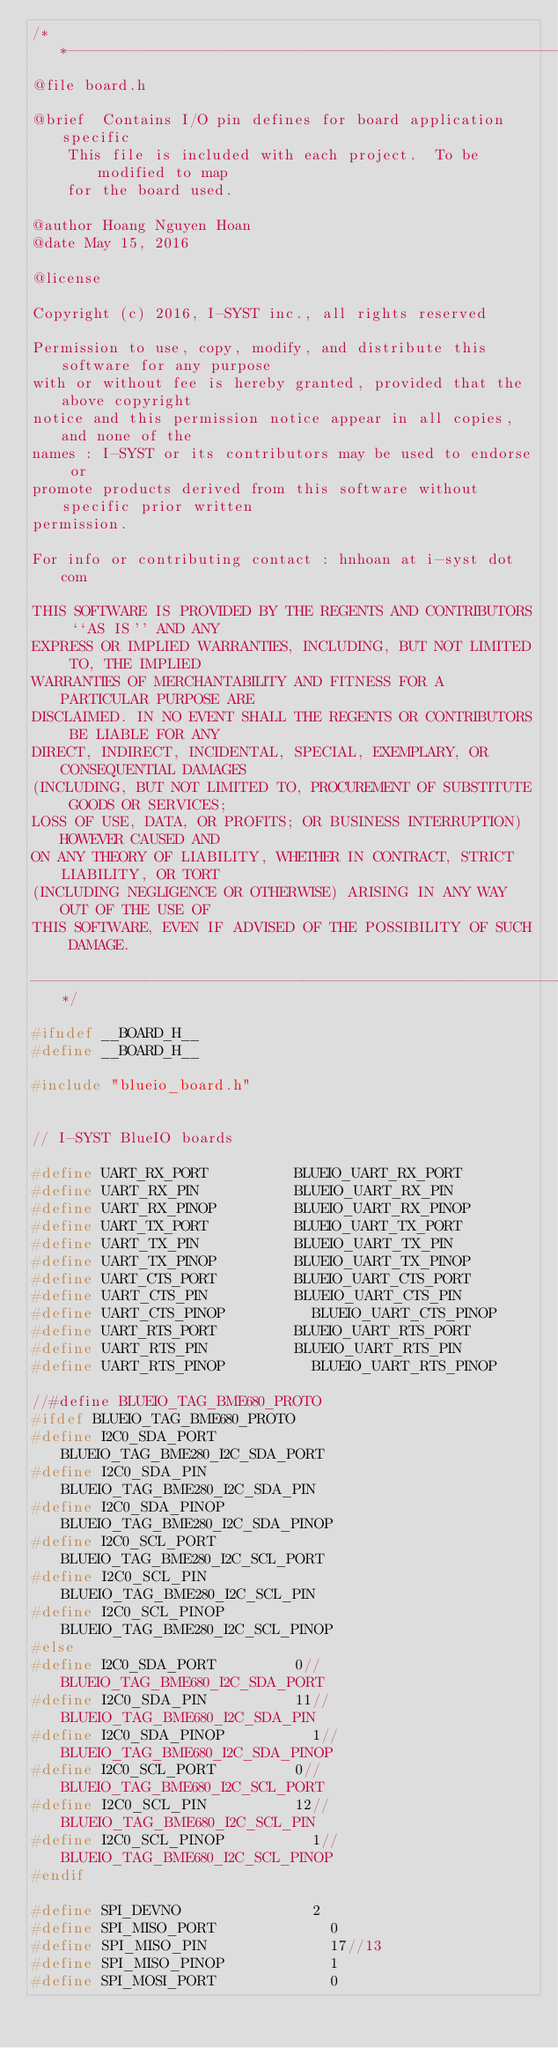Convert code to text. <code><loc_0><loc_0><loc_500><loc_500><_C_>/**-------------------------------------------------------------------------
@file	board.h

@brief	Contains I/O pin defines for board application specific
		This file is included with each project.  To be modified to map
		for the board used.

@author Hoang Nguyen Hoan
@date	May 15, 2016

@license

Copyright (c) 2016, I-SYST inc., all rights reserved

Permission to use, copy, modify, and distribute this software for any purpose
with or without fee is hereby granted, provided that the above copyright
notice and this permission notice appear in all copies, and none of the
names : I-SYST or its contributors may be used to endorse or
promote products derived from this software without specific prior written
permission.

For info or contributing contact : hnhoan at i-syst dot com

THIS SOFTWARE IS PROVIDED BY THE REGENTS AND CONTRIBUTORS ``AS IS'' AND ANY
EXPRESS OR IMPLIED WARRANTIES, INCLUDING, BUT NOT LIMITED TO, THE IMPLIED
WARRANTIES OF MERCHANTABILITY AND FITNESS FOR A PARTICULAR PURPOSE ARE
DISCLAIMED. IN NO EVENT SHALL THE REGENTS OR CONTRIBUTORS BE LIABLE FOR ANY
DIRECT, INDIRECT, INCIDENTAL, SPECIAL, EXEMPLARY, OR CONSEQUENTIAL DAMAGES
(INCLUDING, BUT NOT LIMITED TO, PROCUREMENT OF SUBSTITUTE GOODS OR SERVICES;
LOSS OF USE, DATA, OR PROFITS; OR BUSINESS INTERRUPTION) HOWEVER CAUSED AND
ON ANY THEORY OF LIABILITY, WHETHER IN CONTRACT, STRICT LIABILITY, OR TORT
(INCLUDING NEGLIGENCE OR OTHERWISE) ARISING IN ANY WAY OUT OF THE USE OF
THIS SOFTWARE, EVEN IF ADVISED OF THE POSSIBILITY OF SUCH DAMAGE.

----------------------------------------------------------------------------*/

#ifndef __BOARD_H__
#define __BOARD_H__

#include "blueio_board.h"


// I-SYST BlueIO boards

#define UART_RX_PORT					BLUEIO_UART_RX_PORT
#define UART_RX_PIN						BLUEIO_UART_RX_PIN
#define UART_RX_PINOP					BLUEIO_UART_RX_PINOP
#define UART_TX_PORT					BLUEIO_UART_TX_PORT
#define UART_TX_PIN						BLUEIO_UART_TX_PIN
#define UART_TX_PINOP					BLUEIO_UART_TX_PINOP
#define UART_CTS_PORT					BLUEIO_UART_CTS_PORT
#define UART_CTS_PIN					BLUEIO_UART_CTS_PIN
#define UART_CTS_PINOP					BLUEIO_UART_CTS_PINOP
#define UART_RTS_PORT					BLUEIO_UART_RTS_PORT
#define UART_RTS_PIN					BLUEIO_UART_RTS_PIN
#define UART_RTS_PINOP					BLUEIO_UART_RTS_PINOP

//#define BLUEIO_TAG_BME680_PROTO
#ifdef BLUEIO_TAG_BME680_PROTO
#define I2C0_SDA_PORT					BLUEIO_TAG_BME280_I2C_SDA_PORT
#define I2C0_SDA_PIN					BLUEIO_TAG_BME280_I2C_SDA_PIN
#define I2C0_SDA_PINOP					BLUEIO_TAG_BME280_I2C_SDA_PINOP
#define I2C0_SCL_PORT					BLUEIO_TAG_BME280_I2C_SCL_PORT
#define I2C0_SCL_PIN					BLUEIO_TAG_BME280_I2C_SCL_PIN
#define I2C0_SCL_PINOP					BLUEIO_TAG_BME280_I2C_SCL_PINOP
#else
#define I2C0_SDA_PORT					0//BLUEIO_TAG_BME680_I2C_SDA_PORT
#define I2C0_SDA_PIN					11//BLUEIO_TAG_BME680_I2C_SDA_PIN
#define I2C0_SDA_PINOP					1//BLUEIO_TAG_BME680_I2C_SDA_PINOP
#define I2C0_SCL_PORT					0//BLUEIO_TAG_BME680_I2C_SCL_PORT
#define I2C0_SCL_PIN					12//BLUEIO_TAG_BME680_I2C_SCL_PIN
#define I2C0_SCL_PINOP					1//BLUEIO_TAG_BME680_I2C_SCL_PINOP
#endif

#define SPI_DEVNO      					2
#define SPI_MISO_PORT       			0
#define SPI_MISO_PIN        			17//13
#define SPI_MISO_PINOP      			1
#define SPI_MOSI_PORT       			0</code> 